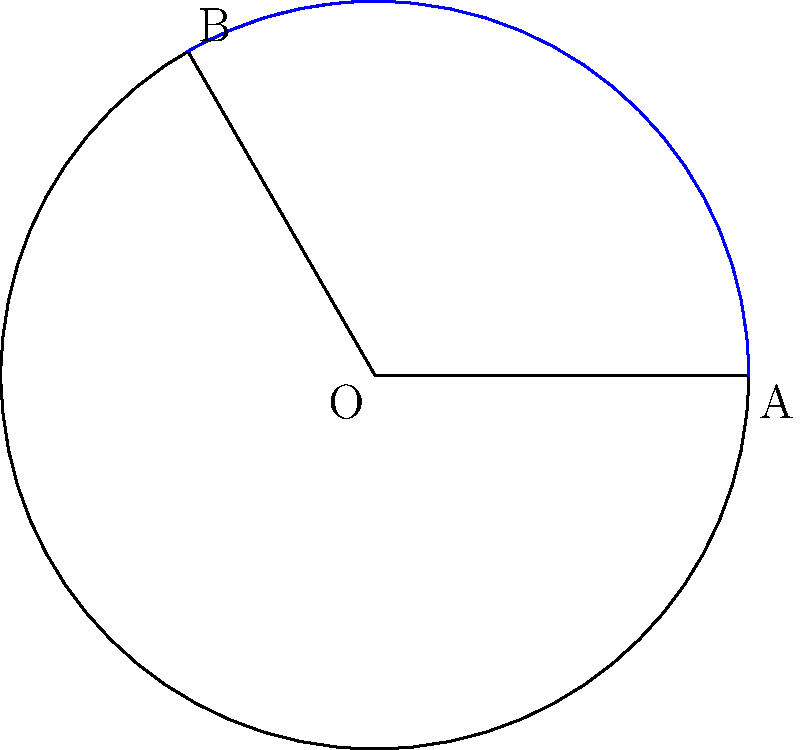In a garden at Wat Phra Kaew, there is a circular pond with a radius of 3 meters. A lotus flower arrangement covers a segment of the pond, forming a central angle of 120°. Calculate the area of the pond covered by the lotus arrangement, rounded to two decimal places. How might this geometric harmony reflect the balance and interconnectedness taught in Buddhist philosophy? To find the area of the circular segment, we'll follow these steps:

1) First, recall the formula for the area of a circular segment:
   $$A = r^2 (\frac{\theta}{2} - \sin\frac{\theta}{2})$$
   where $A$ is the area, $r$ is the radius, and $\theta$ is the central angle in radians.

2) We're given the radius $r = 3$ meters and the central angle $\theta = 120°$.

3) Convert the angle to radians:
   $$120° \times \frac{\pi}{180°} = \frac{2\pi}{3} \approx 2.0944 \text{ radians}$$

4) Now, let's substitute these values into our formula:
   $$A = 3^2 (\frac{2\pi/3}{2} - \sin\frac{2\pi/3}{2})$$

5) Simplify:
   $$A = 9 (\frac{\pi}{3} - \sin\frac{\pi}{3})$$

6) We know that $\sin\frac{\pi}{3} = \frac{\sqrt{3}}{2}$, so:
   $$A = 9 (\frac{\pi}{3} - \frac{\sqrt{3}}{2})$$

7) Calculate:
   $$A \approx 9 (1.0472 - 0.8660) \approx 1.6308 \text{ square meters}$$

8) Rounding to two decimal places:
   $$A \approx 1.63 \text{ square meters}$$

This geometric harmony in the garden reflects the Buddhist concepts of balance and interconnectedness. The circular shape represents the cyclical nature of existence, while the segment symbolizes how all parts are connected to the whole, much like how all beings are interconnected in Buddhist philosophy.
Answer: 1.63 m² 